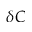<formula> <loc_0><loc_0><loc_500><loc_500>\delta C</formula> 